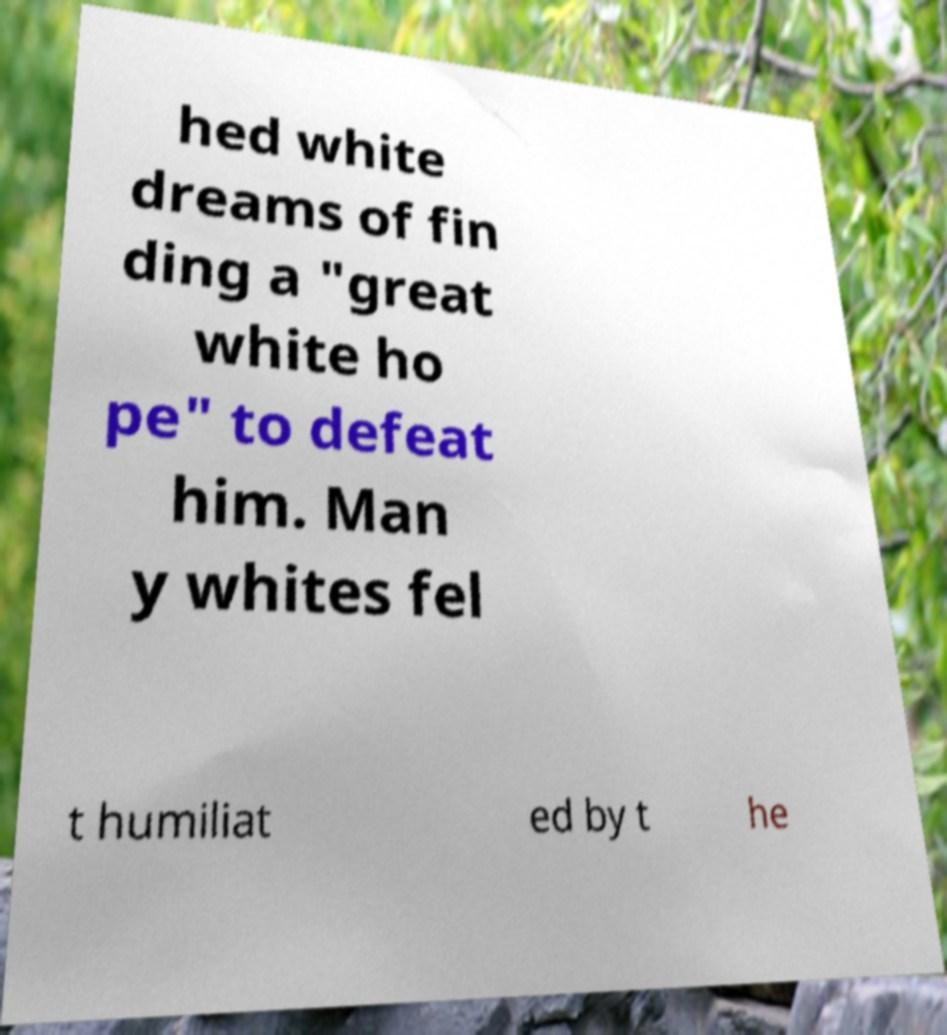Can you accurately transcribe the text from the provided image for me? hed white dreams of fin ding a "great white ho pe" to defeat him. Man y whites fel t humiliat ed by t he 